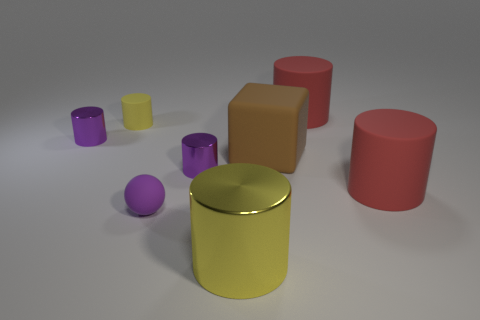There is a shiny object that is to the right of the tiny purple rubber ball and behind the sphere; what shape is it?
Offer a terse response. Cylinder. What number of other objects are the same shape as the big yellow object?
Give a very brief answer. 5. There is a rubber object that is the same size as the purple ball; what color is it?
Make the answer very short. Yellow. How many things are either big yellow metal things or brown things?
Your response must be concise. 2. There is a purple sphere; are there any small rubber spheres in front of it?
Your answer should be very brief. No. Is there a large cylinder made of the same material as the block?
Offer a very short reply. Yes. What is the size of the other cylinder that is the same color as the small rubber cylinder?
Your answer should be compact. Large. How many blocks are big green objects or purple objects?
Provide a short and direct response. 0. Is the number of spheres that are to the right of the brown thing greater than the number of large red objects that are in front of the small yellow cylinder?
Keep it short and to the point. No. How many large things have the same color as the matte cube?
Keep it short and to the point. 0. 